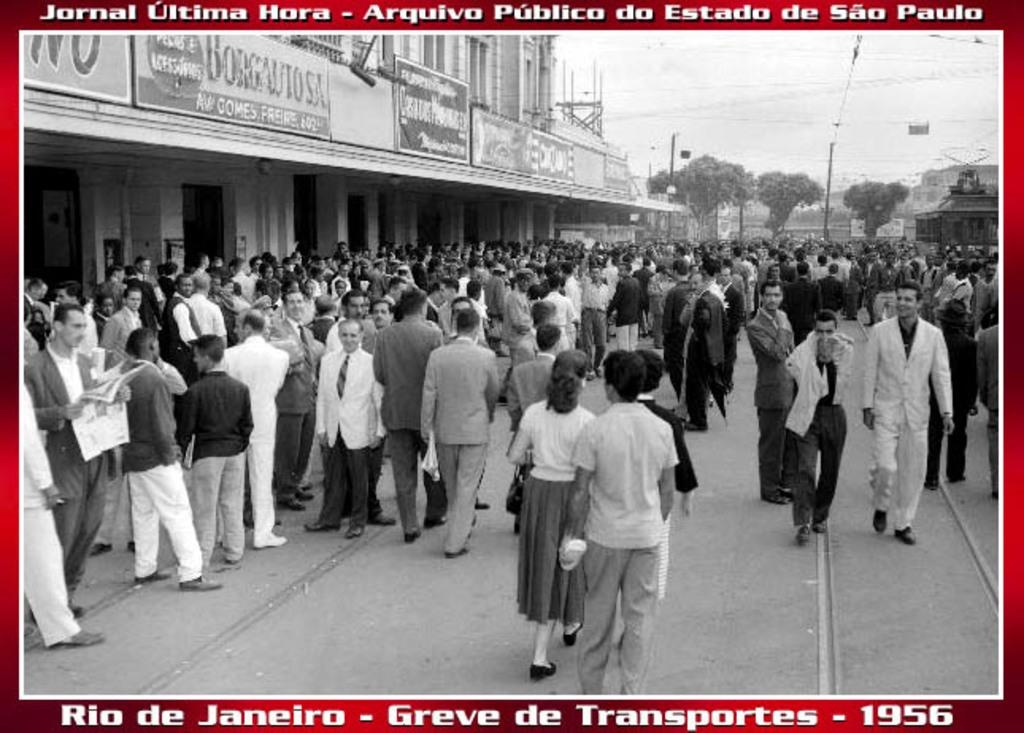Provide a one-sentence caption for the provided image. A postcard from Rio De Janeiro in 1956. 